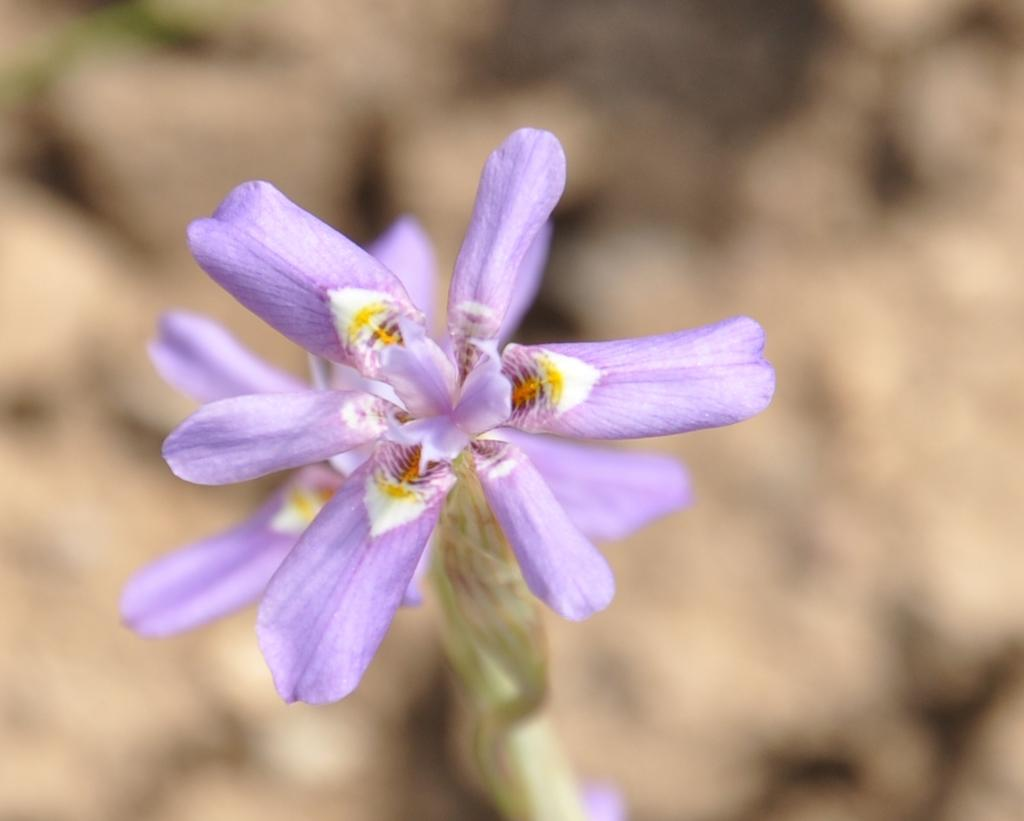What type of living organisms can be seen in the image? Flowers are visible in the image. Can you describe the flowers in the image? Unfortunately, the facts provided do not give specific details about the flowers. What might be the purpose of the flowers in the image? The purpose of the flowers in the image cannot be determined from the provided facts. What type of teeth can be seen on the flowers in the image? There are no teeth present on the flowers in the image, as flowers do not have teeth. 